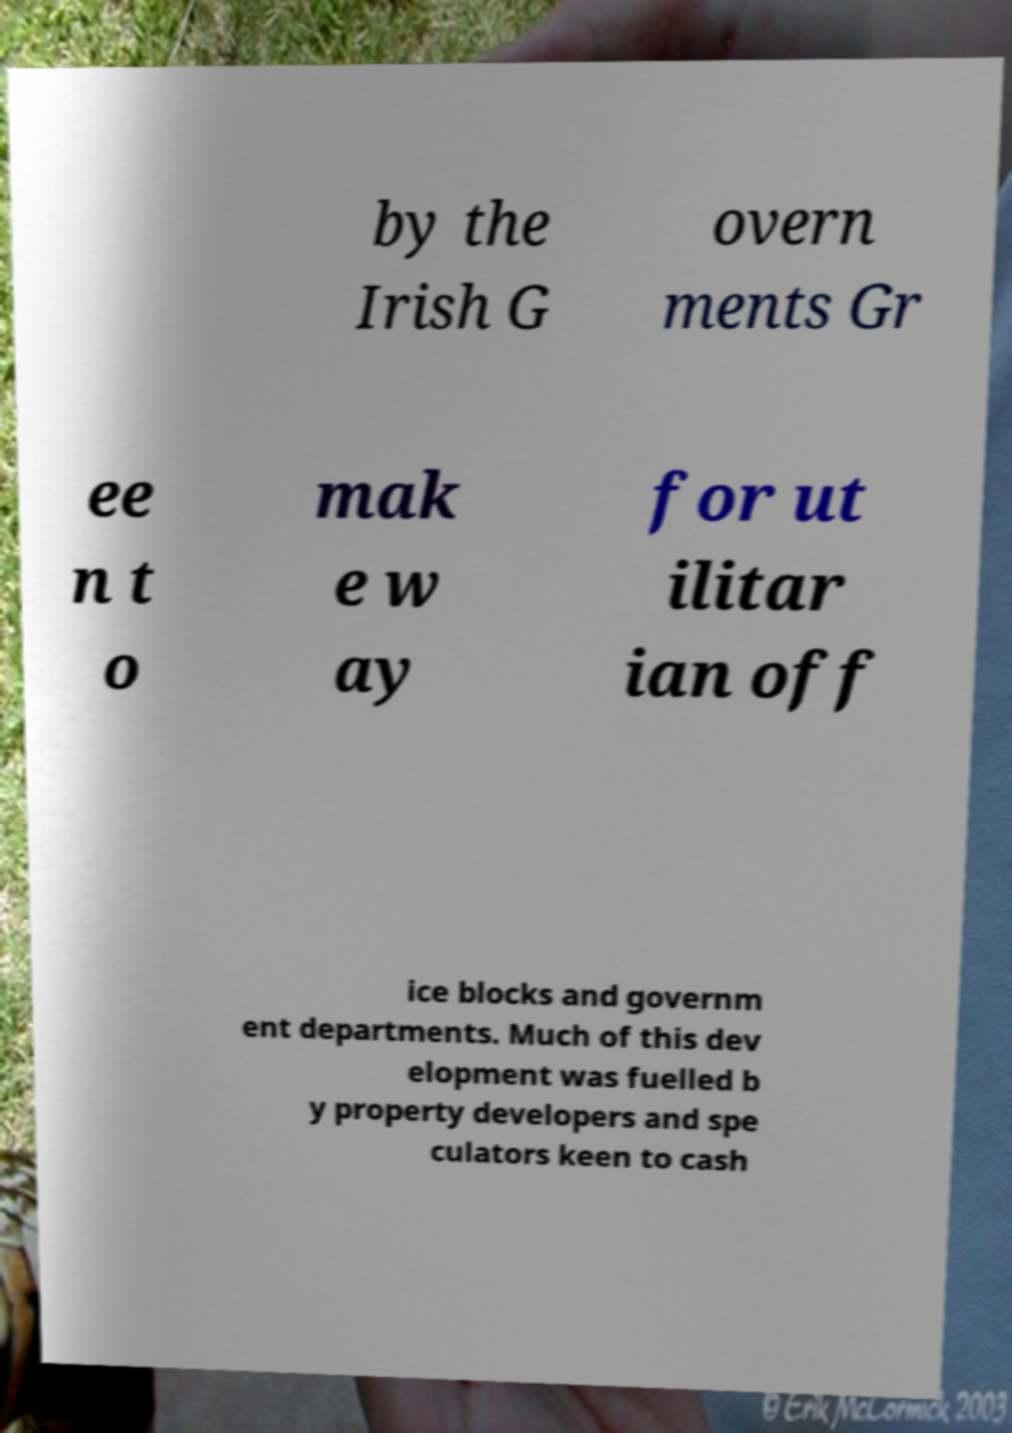Please identify and transcribe the text found in this image. by the Irish G overn ments Gr ee n t o mak e w ay for ut ilitar ian off ice blocks and governm ent departments. Much of this dev elopment was fuelled b y property developers and spe culators keen to cash 